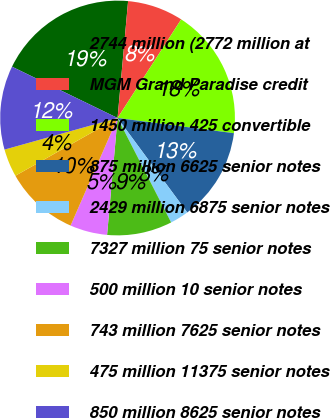<chart> <loc_0><loc_0><loc_500><loc_500><pie_chart><fcel>2744 million (2772 million at<fcel>MGM Grand Paradise credit<fcel>1450 million 425 convertible<fcel>875 million 6625 senior notes<fcel>2429 million 6875 senior notes<fcel>7327 million 75 senior notes<fcel>500 million 10 senior notes<fcel>743 million 7625 senior notes<fcel>475 million 11375 senior notes<fcel>850 million 8625 senior notes<nl><fcel>19.23%<fcel>7.69%<fcel>17.95%<fcel>12.82%<fcel>2.57%<fcel>8.97%<fcel>5.13%<fcel>10.26%<fcel>3.85%<fcel>11.54%<nl></chart> 